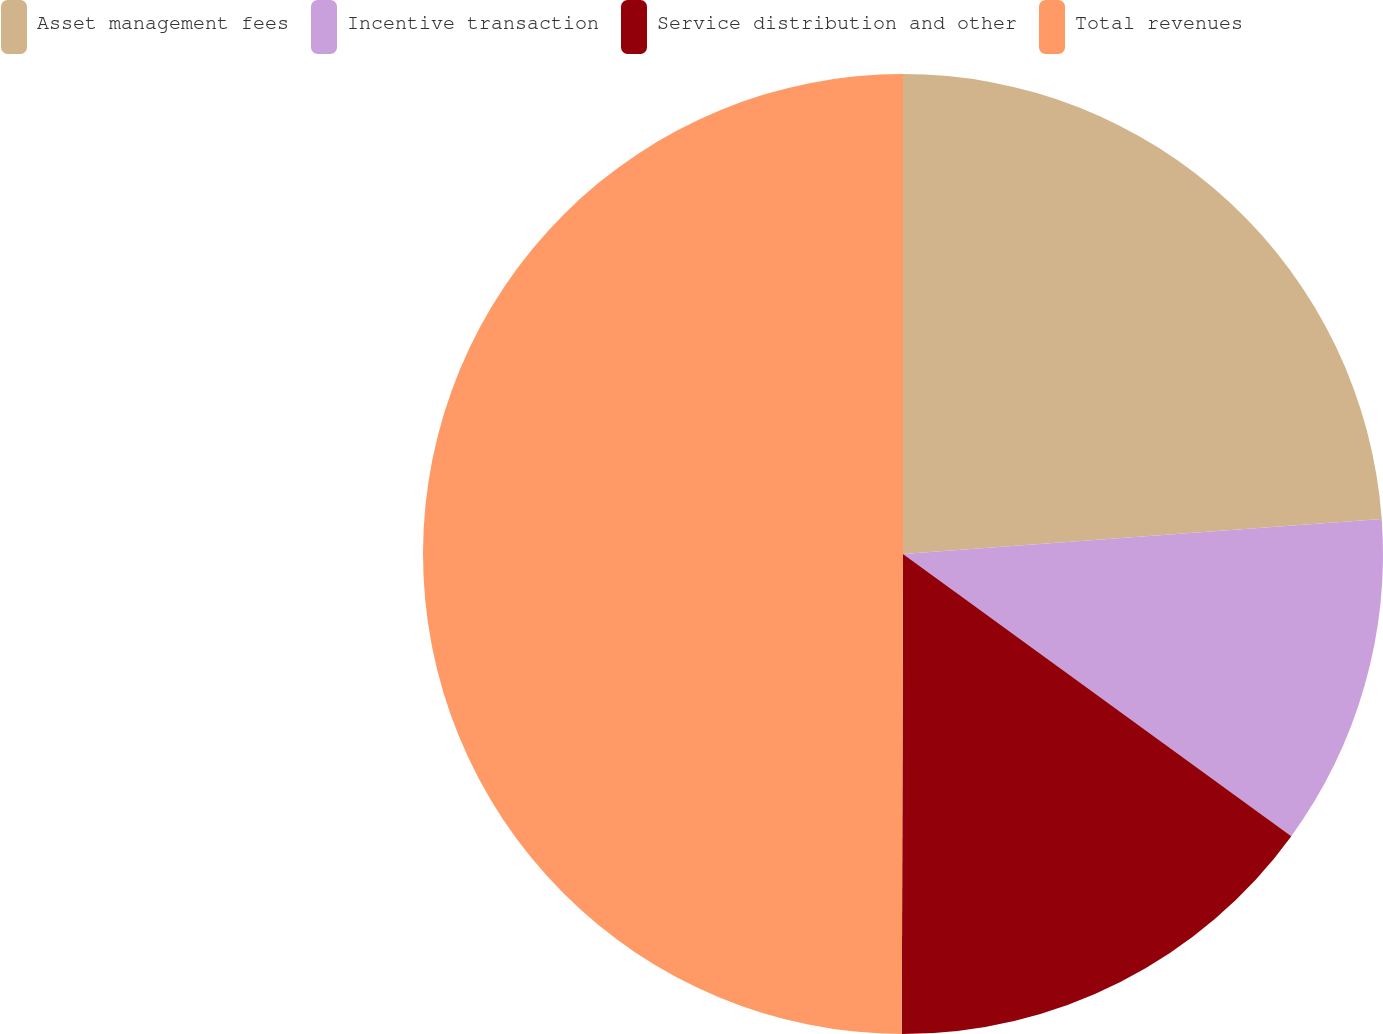Convert chart. <chart><loc_0><loc_0><loc_500><loc_500><pie_chart><fcel>Asset management fees<fcel>Incentive transaction<fcel>Service distribution and other<fcel>Total revenues<nl><fcel>23.84%<fcel>11.16%<fcel>15.04%<fcel>49.96%<nl></chart> 